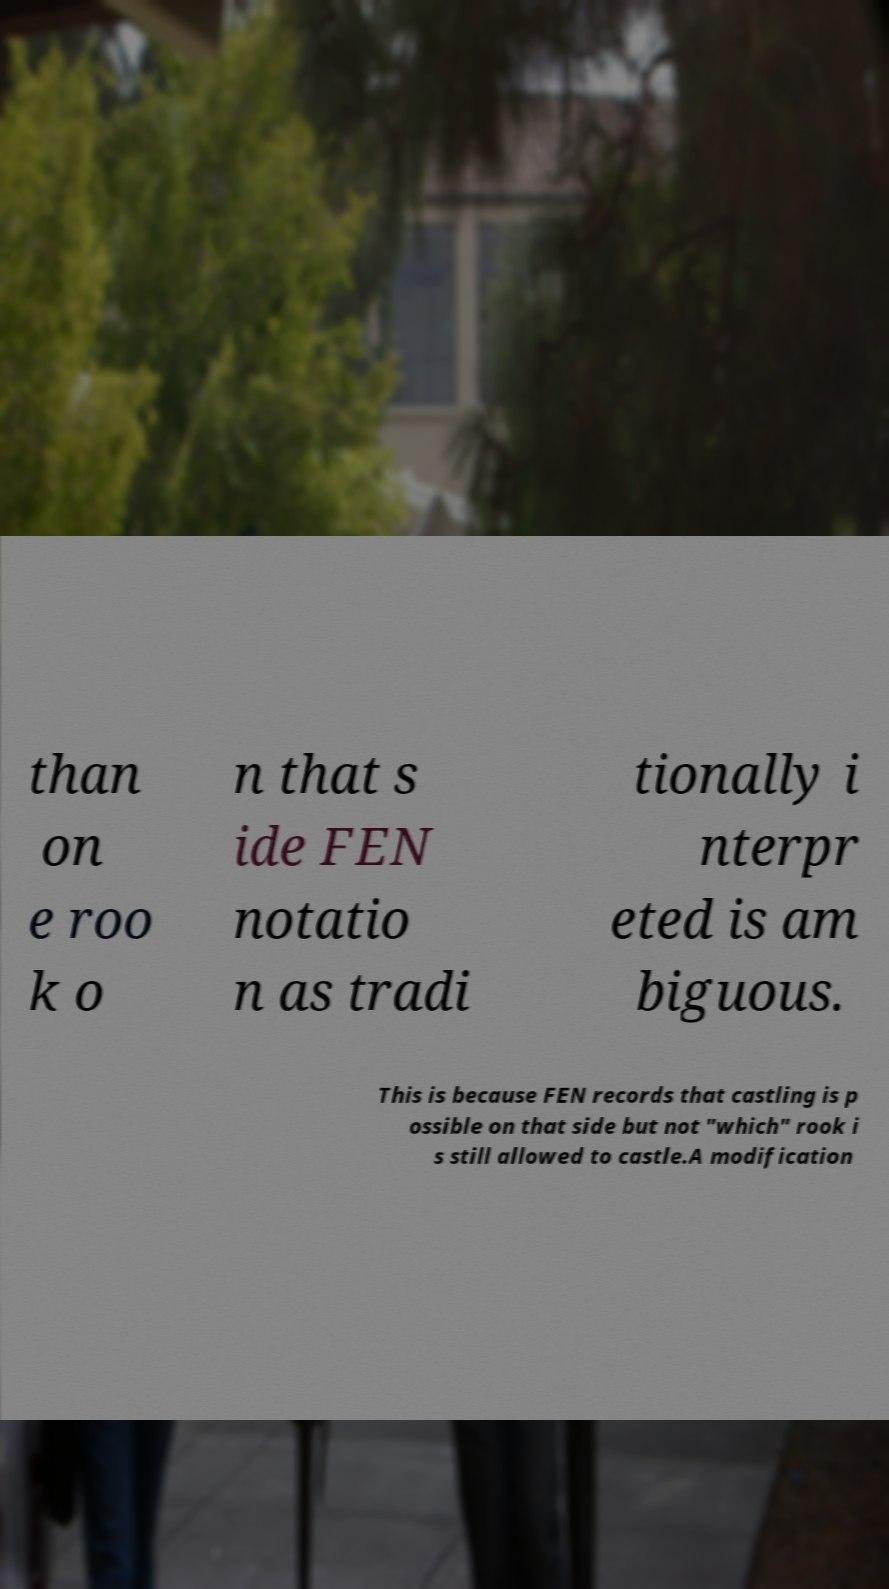I need the written content from this picture converted into text. Can you do that? than on e roo k o n that s ide FEN notatio n as tradi tionally i nterpr eted is am biguous. This is because FEN records that castling is p ossible on that side but not "which" rook i s still allowed to castle.A modification 